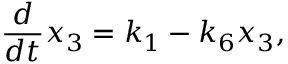Convert formula to latex. <formula><loc_0><loc_0><loc_500><loc_500>\frac { d } { d t } x _ { 3 } = k _ { 1 } - k _ { 6 } x _ { 3 } ,</formula> 